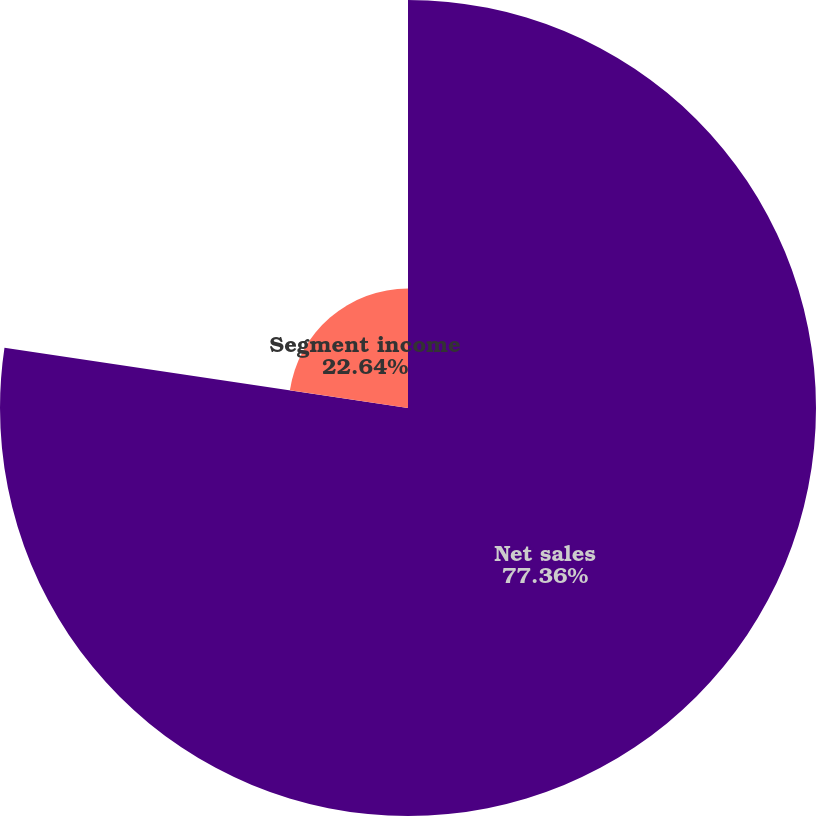Convert chart to OTSL. <chart><loc_0><loc_0><loc_500><loc_500><pie_chart><fcel>Net sales<fcel>Segment income<nl><fcel>77.36%<fcel>22.64%<nl></chart> 